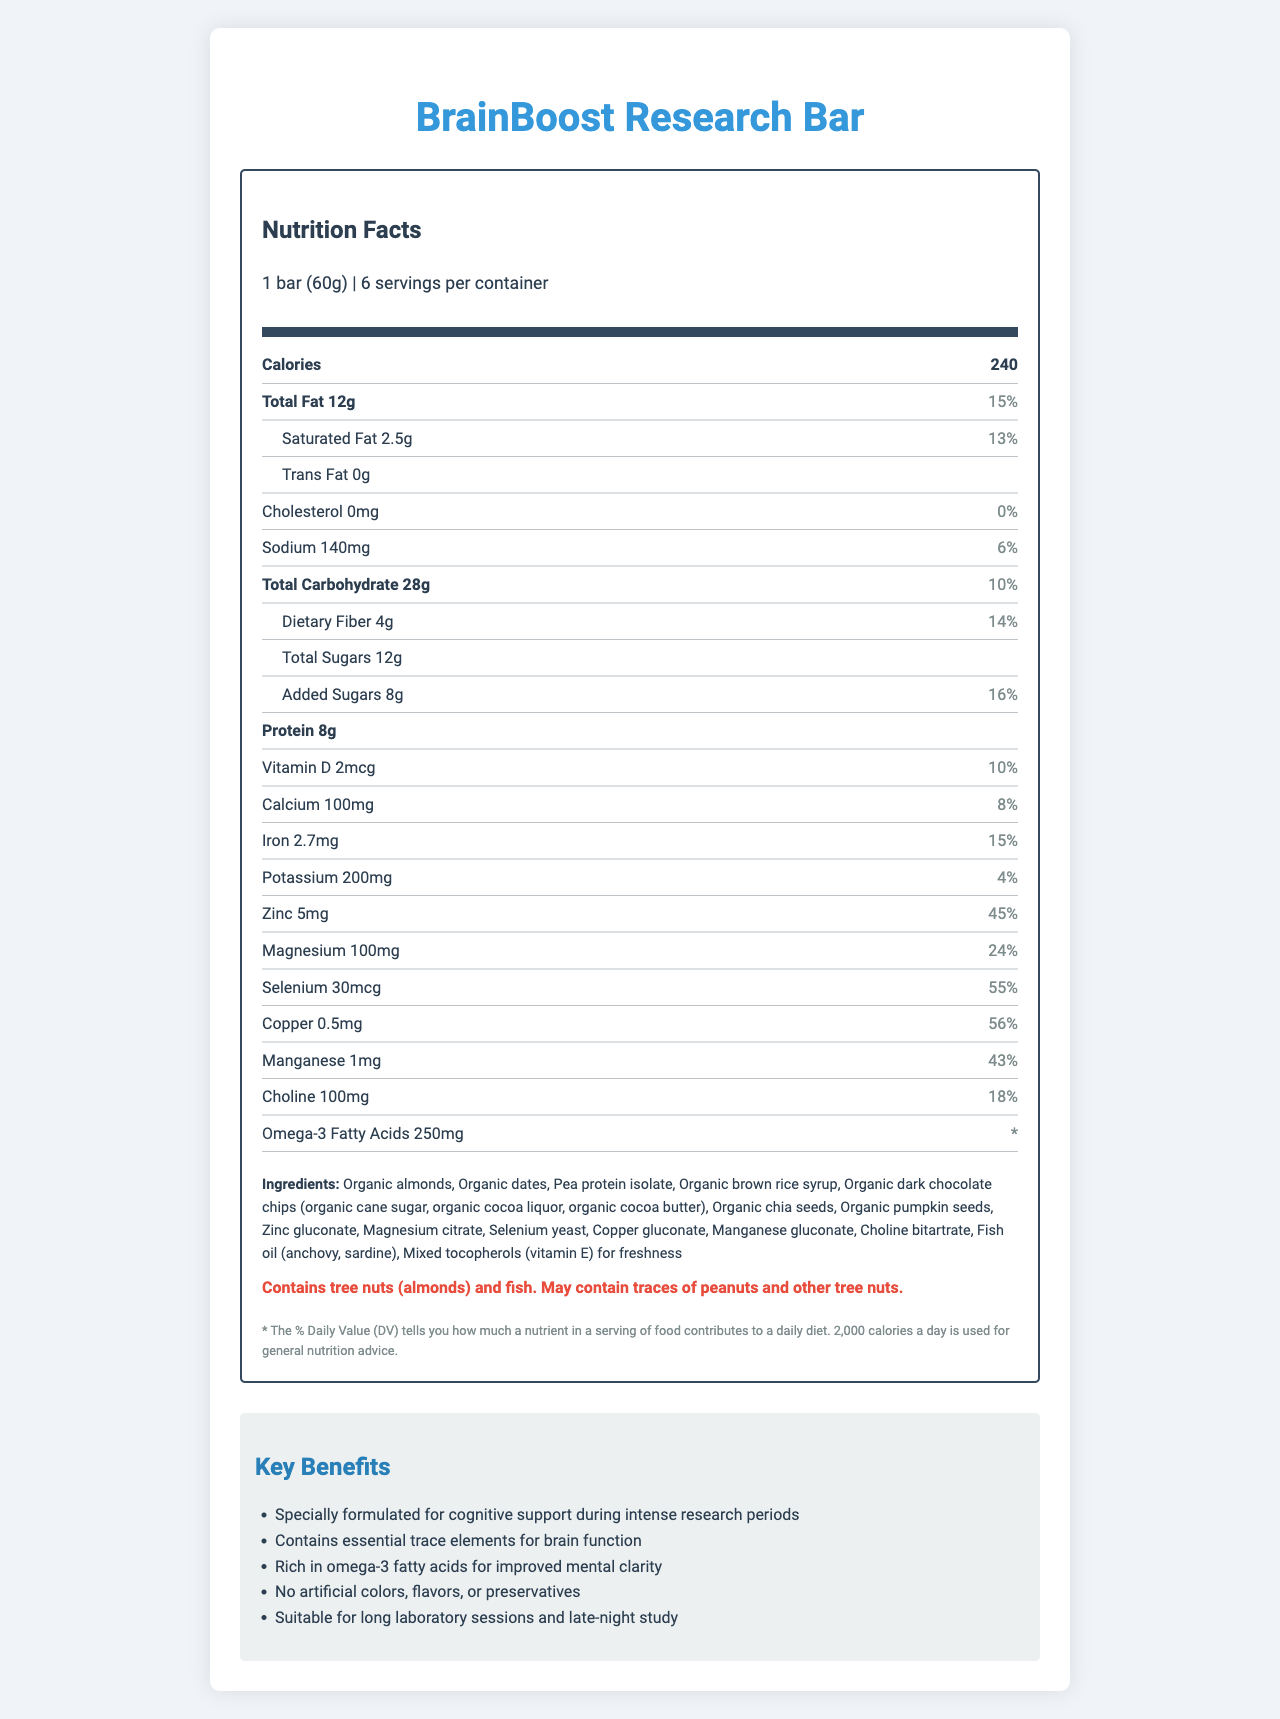what is the serving size of the BrainBoost Research Bar? The serving size is clearly stated as "1 bar (60g)" in the document.
Answer: 1 bar (60g) how many calories are in one serving of the BrainBoost Research Bar? The document mentions that there are 240 calories per serving of the snack bar.
Answer: 240 calories what is the amount of total fat in one serving, and what is its daily value percentage? The document states that one serving contains 12g of total fat, which is 15% of the daily value.
Answer: 12g, 15% how much dietary fiber does one serving contain, and what percentage of the daily value does it represent? The document indicates that one serving contains 4g of dietary fiber, providing 14% of the daily value.
Answer: 4g, 14% can someone with a peanut allergy consume the BrainBoost Research Bar? The allergen information specifies that the product "may contain traces of peanuts," thus it may not be safe for someone with a peanut allergy.
Answer: No, due to potential traces of peanuts. what mineral has the highest daily value percentage in the BrainBoost Research Bar? The document indicates that copper has the highest daily value percentage of 56%.
Answer: Copper, 56% which product marketing claim is NOT mentioned in the document? A. Rich in omega-3 fatty acids for improved mental clarity B. Contains essential trace elements for brain function C. Certified organic D. Suitable for long laboratory sessions and late-night study The document does not mention that the product is certified organic.
Answer: C. Certified organic what is the daily value percentage for magnesium per serving? A. 24% B. 43% C. 55% D. 56% The document specifies that magnesium has a daily value of 24%.
Answer: A. 24% are trans fats present in the BrainBoost Research Bar? The document states that the amount of trans fat is 0g, indicating there are no trans fats present.
Answer: No is the BrainBoost Research Bar free from artificial colors, flavors, or preservatives? One of the marketing claims in the document specifically states that the product contains "No artificial colors, flavors, or preservatives."
Answer: Yes summarize the main idea of the document The document includes various sections like nutrition facts, ingredients, allergen information, and marketing claims. These sections collectively aim to communicate the health benefits and nutritional composition of the product, targeting individuals involved in intense research activities.
Answer: The main idea of the document is to provide detailed nutritional information about the BrainBoost Research Bar, emphasizing its formulation for cognitive support with essential trace elements and omega-3 fatty acids, while highlighting its natural ingredients and lack of artificial additives. what other trace elements are included in the BrainBoost Research Bar besides copper? The document lists several other trace elements: zinc (5mg, 45% DV), magnesium (100mg, 24% DV), selenium (30mcg, 55% DV), and manganese (1mg, 43% DV).
Answer: Zinc, Magnesium, Selenium, Manganese how much choline does one serving of the BrainBoost Research Bar provide? The document states that one serving contains 100mg of choline, contributing 18% to the daily value.
Answer: 100mg can the nutritional effects of the BrainBoost Research Bar be fully understood without consuming it over a longer period? The document does not provide information on long-term studies or personal testimonials, so it is unclear if the nutritional effects can be fully appreciated without prolonged consumption.
Answer: Cannot be determined what is the total carbohydrate content and its daily value percentage in one serving? The document indicates that one serving contains 28g of total carbohydrates, which is 10% of the daily value.
Answer: 28g, 10% 